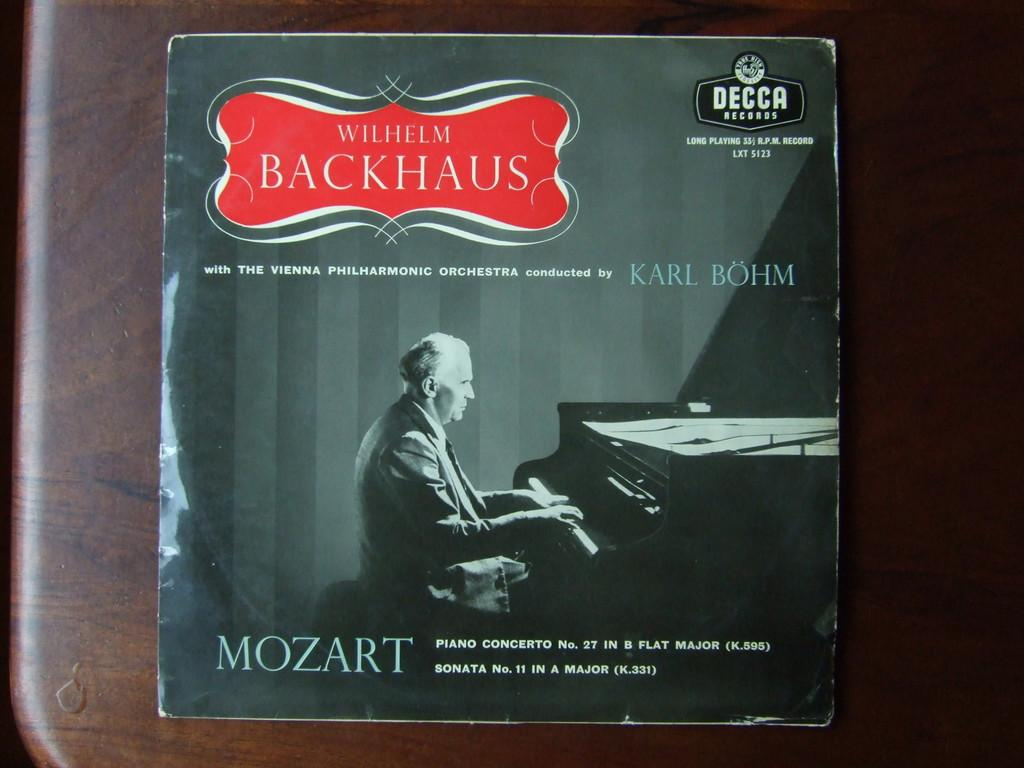<image>
Provide a brief description of the given image. A man sits at a piano under the name Wilhelm Backhaus. 